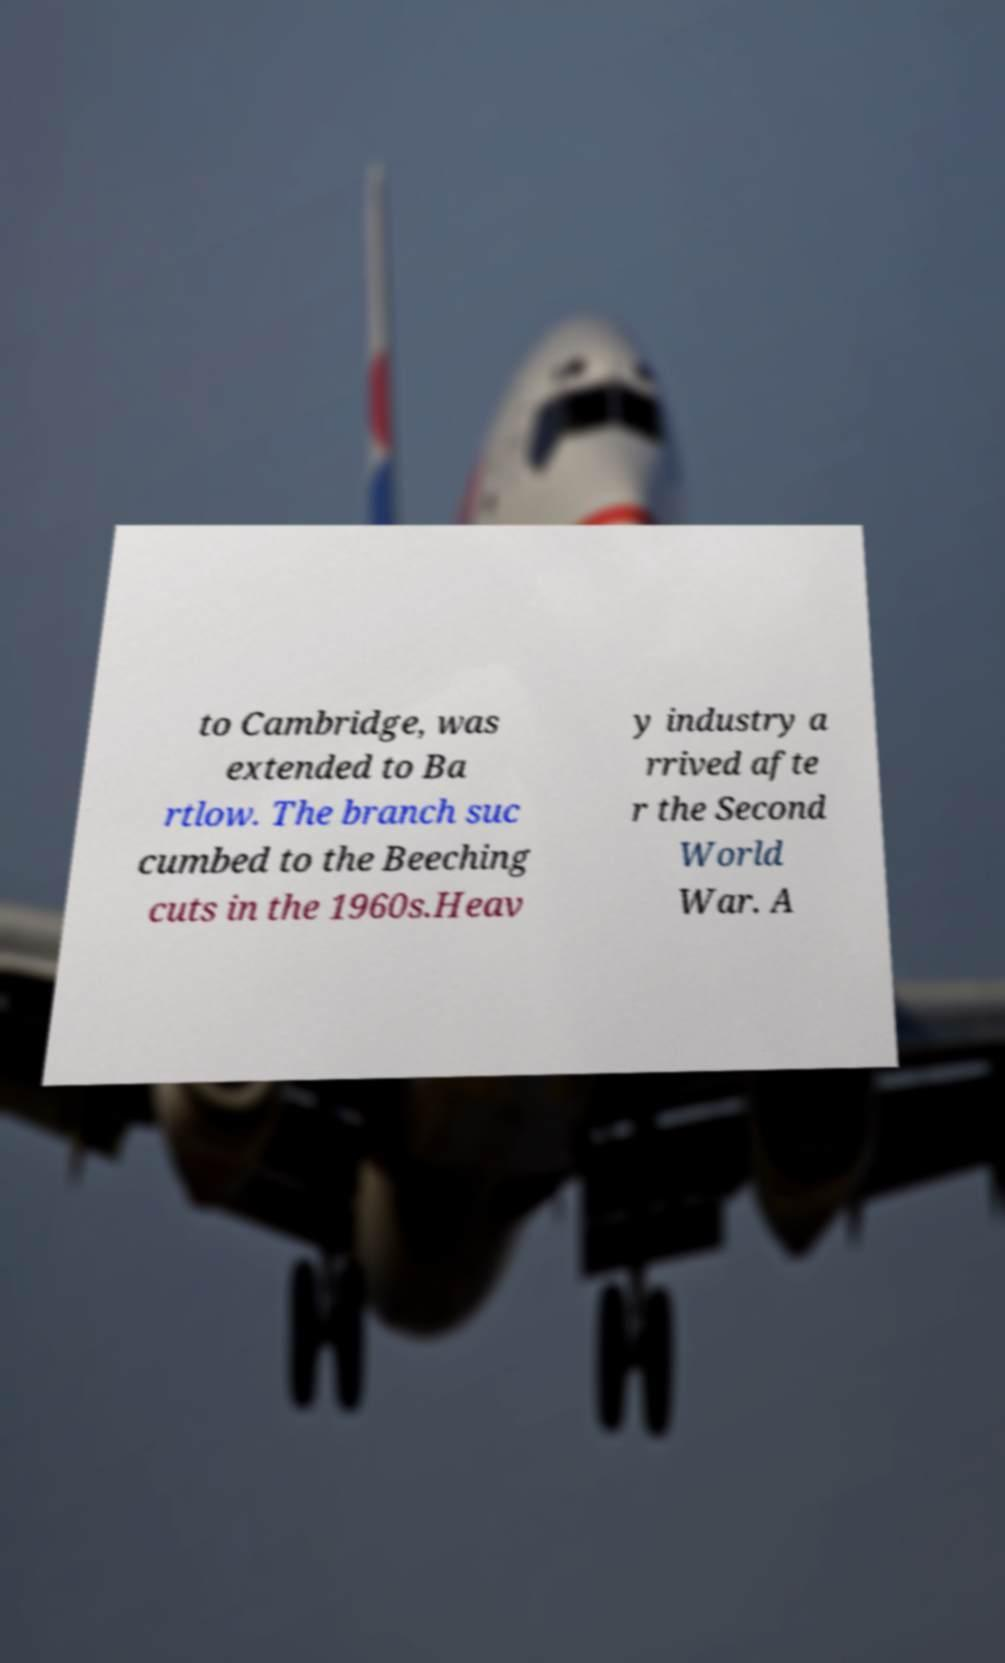What messages or text are displayed in this image? I need them in a readable, typed format. to Cambridge, was extended to Ba rtlow. The branch suc cumbed to the Beeching cuts in the 1960s.Heav y industry a rrived afte r the Second World War. A 